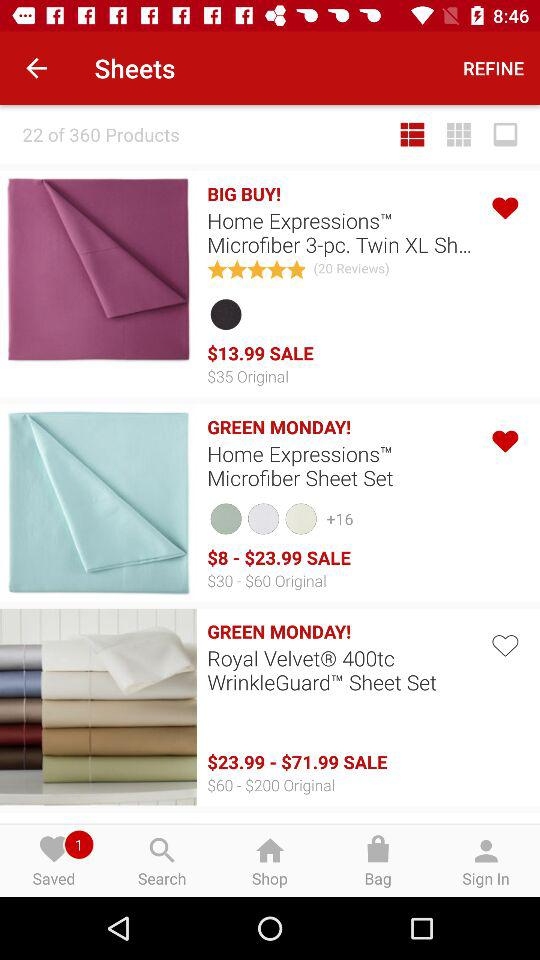How many reviews are there for the Home Expressions Microfiber Sheet Set?
When the provided information is insufficient, respond with <no answer>. <no answer> 